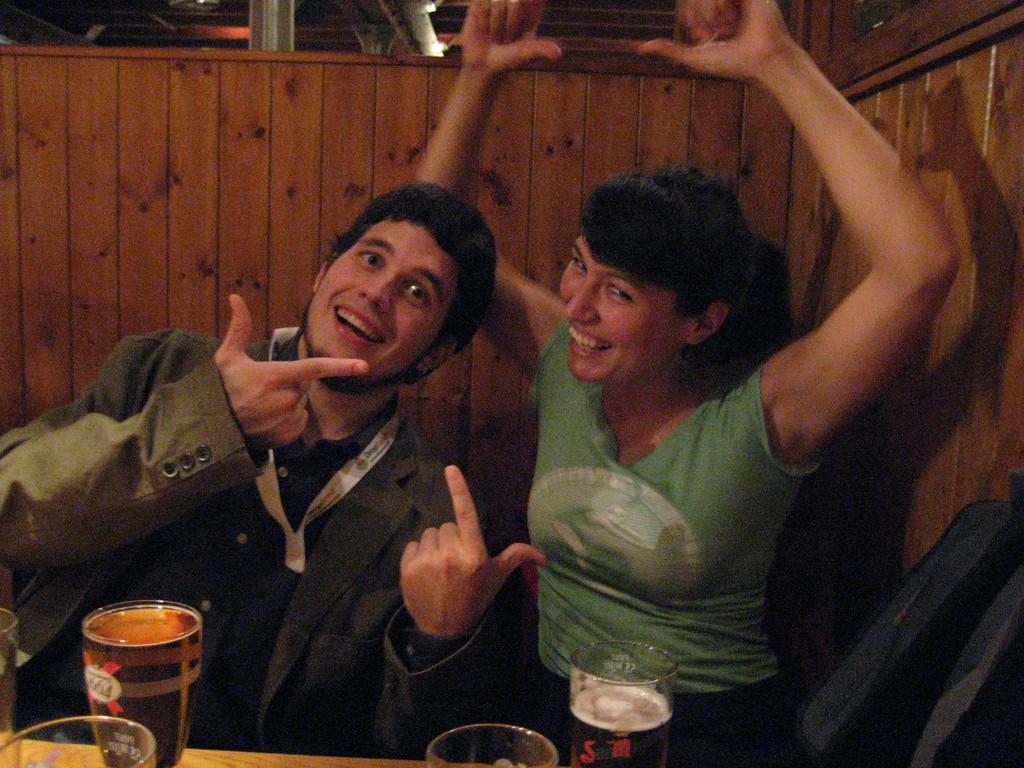Describe this image in one or two sentences. In the picture I can see a man, a woman are sitting and smiling. Here I can see glasses and tin can on the table. In the background I can see wooden wall and some other objects. 